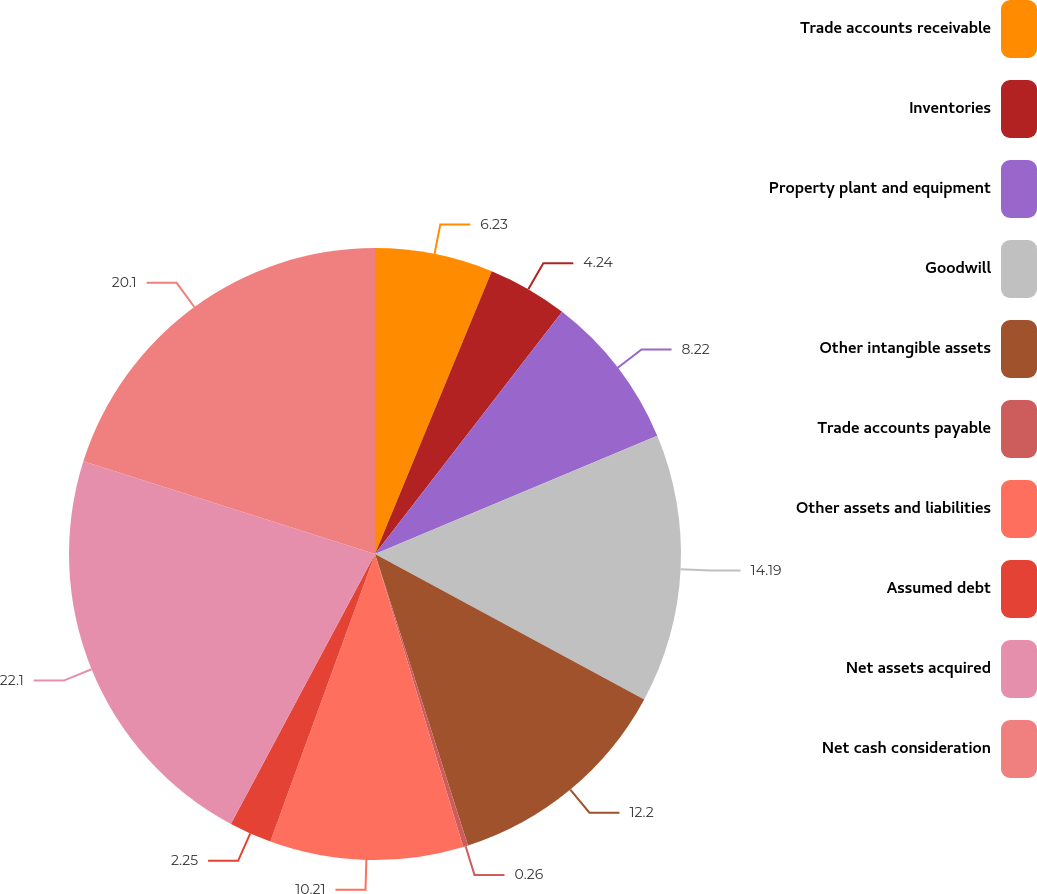Convert chart. <chart><loc_0><loc_0><loc_500><loc_500><pie_chart><fcel>Trade accounts receivable<fcel>Inventories<fcel>Property plant and equipment<fcel>Goodwill<fcel>Other intangible assets<fcel>Trade accounts payable<fcel>Other assets and liabilities<fcel>Assumed debt<fcel>Net assets acquired<fcel>Net cash consideration<nl><fcel>6.23%<fcel>4.24%<fcel>8.22%<fcel>14.19%<fcel>12.2%<fcel>0.26%<fcel>10.21%<fcel>2.25%<fcel>22.09%<fcel>20.1%<nl></chart> 